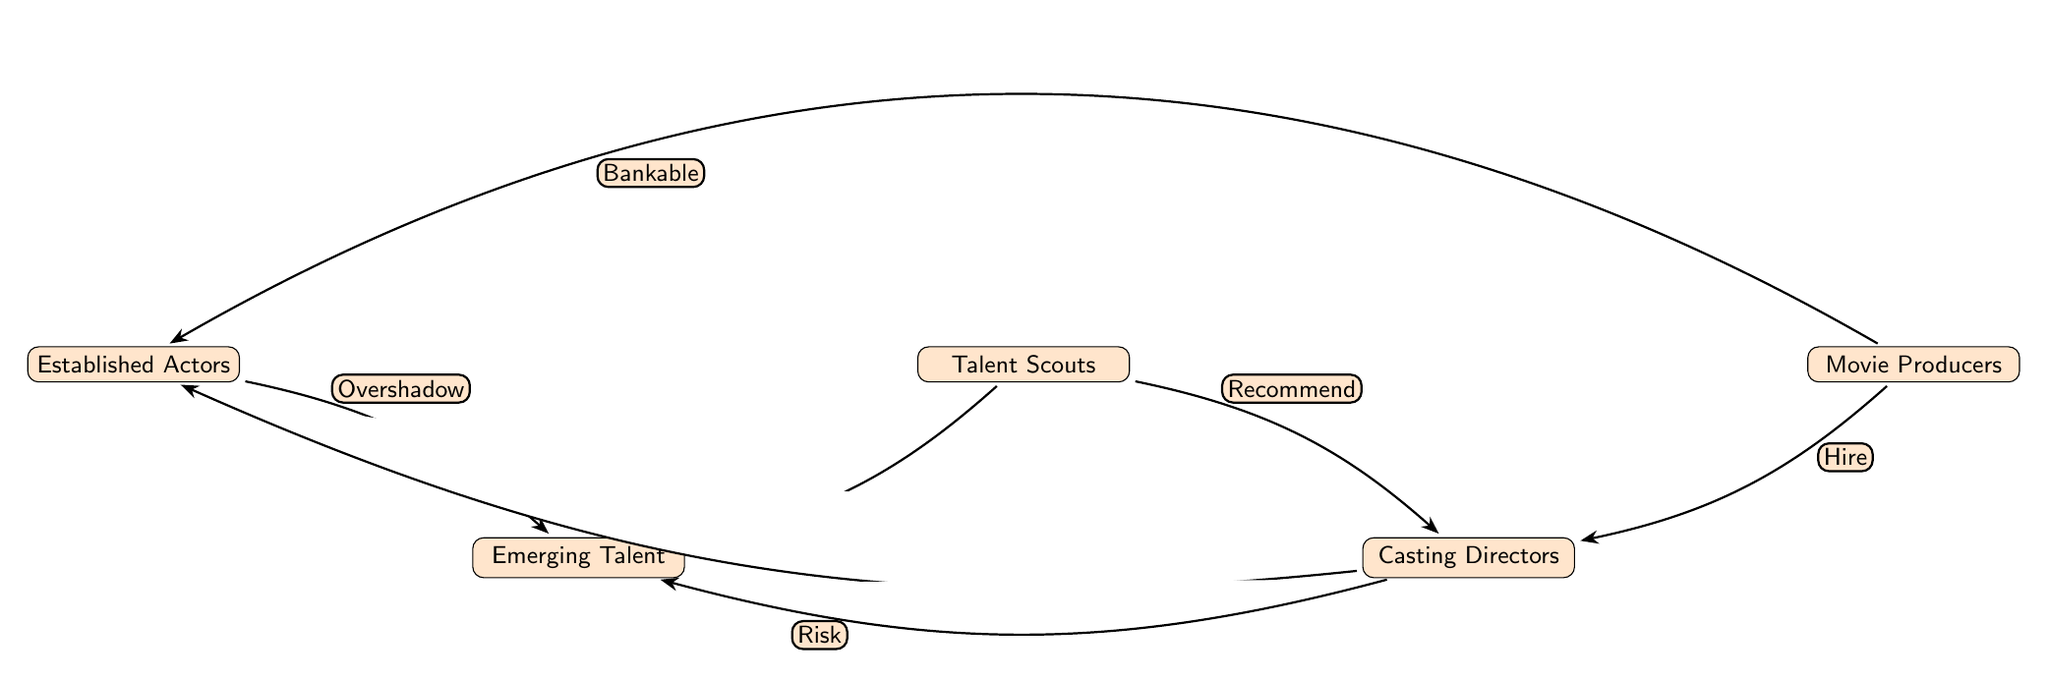What is the top node in the diagram? The top node in the diagram represents the "Established Actors," which is positioned at the topmost level.
Answer: Established Actors How many nodes are present in the diagram? By counting all the distinct entities in the diagram, we find there are five nodes in total: Established Actors, Emerging Talent, Talent Scouts, Casting Directors, and Movie Producers.
Answer: 5 What connection is made between Talent Scouts and Emerging Talent? The diagram indicates that Talent Scouts "Discover" Emerging Talent, which establishes a direct relationship and action flow between these two nodes.
Answer: Discover Which node does Casting Directors favor? Based on the diagram, Casting Directors are shown to "Favor" Established Actors, indicating a preference in their scouting and casting decisions.
Answer: Established Actors What role do Movie Producers play in this diagram? Movie Producers "Hire" Casting Directors, showing that they are involved in the final decision-making regarding which actors get cast in films.
Answer: Hire What risk is associated with the relationship between Casting Directors and Emerging Talent? The diagram specifies that Casting Directors take a "Risk" when deciding to work with Emerging Talent, suggesting a caution exercised when casting less established actors.
Answer: Risk How do Talent Scouts influence Casting Directors? Talent Scouts "Recommend" Emerging Talent to Casting Directors, indicating a supportive relationship where scouts guide casting choices.
Answer: Recommend What is the function of Established Actors in the context of the diagram? Established Actors are shown to "Overshadow" Emerging Talent, suggesting that their presence may limit the visibility or opportunities for newer talents.
Answer: Overshadow What is a reason for Movie Producers to favor Established Actors? The diagram indicates that Movie Producers may choose Established Actors due to their being "Bankable," which suggests a commercial value or proven success in the industry.
Answer: Bankable 